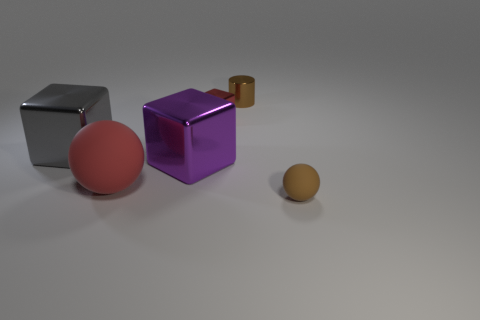Add 4 large red rubber balls. How many objects exist? 10 Subtract all cyan balls. Subtract all brown cylinders. How many balls are left? 2 Subtract all balls. How many objects are left? 4 Subtract 0 brown cubes. How many objects are left? 6 Subtract all small blue metal blocks. Subtract all large balls. How many objects are left? 5 Add 3 large balls. How many large balls are left? 4 Add 2 tiny blue matte cylinders. How many tiny blue matte cylinders exist? 2 